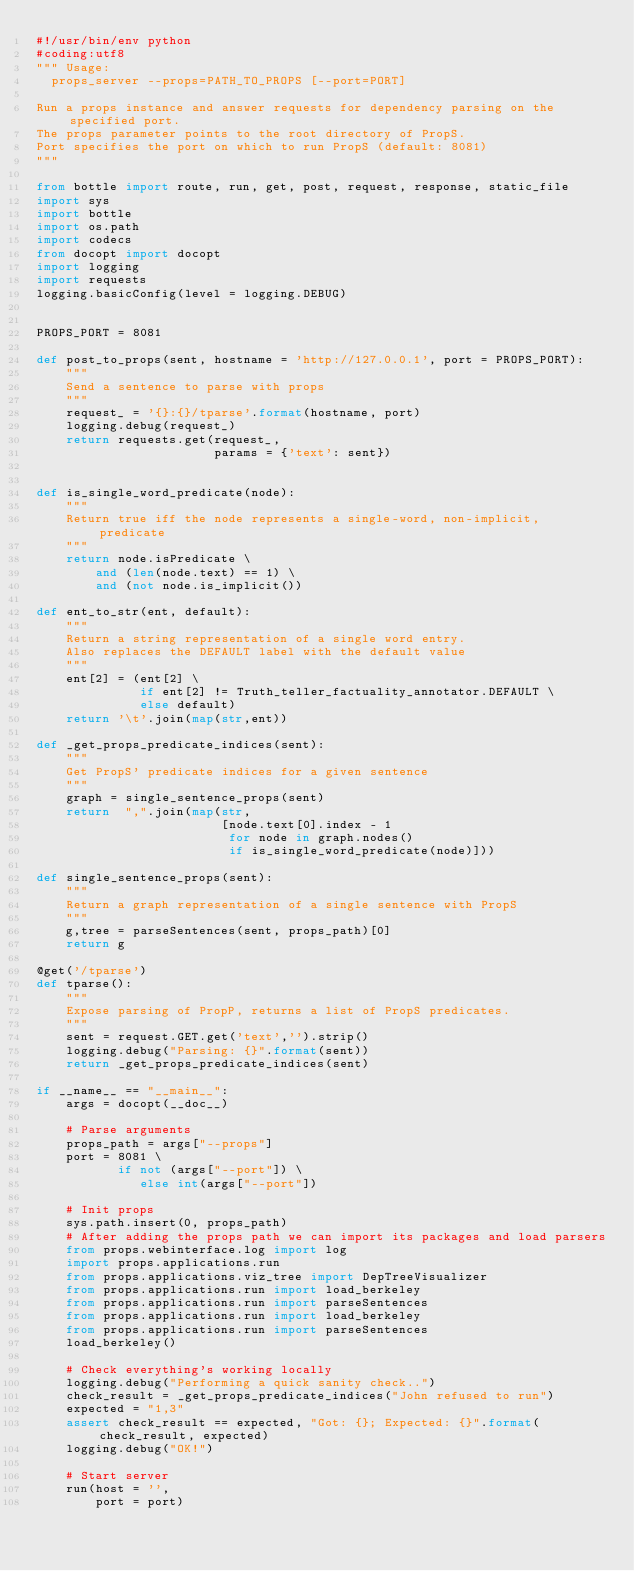Convert code to text. <code><loc_0><loc_0><loc_500><loc_500><_Python_>#!/usr/bin/env python
#coding:utf8
""" Usage:
  props_server --props=PATH_TO_PROPS [--port=PORT]

Run a props instance and answer requests for dependency parsing on the specified port.
The props parameter points to the root directory of PropS.
Port specifies the port on which to run PropS (default: 8081)
"""

from bottle import route, run, get, post, request, response, static_file
import sys
import bottle
import os.path
import codecs
from docopt import docopt
import logging
import requests
logging.basicConfig(level = logging.DEBUG)


PROPS_PORT = 8081

def post_to_props(sent, hostname = 'http://127.0.0.1', port = PROPS_PORT):
    """
    Send a sentence to parse with props
    """
    request_ = '{}:{}/tparse'.format(hostname, port)
    logging.debug(request_)
    return requests.get(request_,
                        params = {'text': sent})


def is_single_word_predicate(node):
    """
    Return true iff the node represents a single-word, non-implicit, predicate
    """
    return node.isPredicate \
        and (len(node.text) == 1) \
        and (not node.is_implicit())

def ent_to_str(ent, default):
    """
    Return a string representation of a single word entry.
    Also replaces the DEFAULT label with the default value
    """
    ent[2] = (ent[2] \
              if ent[2] != Truth_teller_factuality_annotator.DEFAULT \
              else default)
    return '\t'.join(map(str,ent))

def _get_props_predicate_indices(sent):
    """
    Get PropS' predicate indices for a given sentence
    """
    graph = single_sentence_props(sent)
    return  ",".join(map(str,
                         [node.text[0].index - 1
                          for node in graph.nodes()
                          if is_single_word_predicate(node)]))

def single_sentence_props(sent):
    """
    Return a graph representation of a single sentence with PropS
    """
    g,tree = parseSentences(sent, props_path)[0]
    return g

@get('/tparse')
def tparse():
    """
    Expose parsing of PropP, returns a list of PropS predicates.
    """
    sent = request.GET.get('text','').strip()
    logging.debug("Parsing: {}".format(sent))
    return _get_props_predicate_indices(sent)

if __name__ == "__main__":
    args = docopt(__doc__)

    # Parse arguments
    props_path = args["--props"]
    port = 8081 \
           if not (args["--port"]) \
              else int(args["--port"])

    # Init props
    sys.path.insert(0, props_path)
    # After adding the props path we can import its packages and load parsers
    from props.webinterface.log import log
    import props.applications.run
    from props.applications.viz_tree import DepTreeVisualizer
    from props.applications.run import load_berkeley
    from props.applications.run import parseSentences
    from props.applications.run import load_berkeley
    from props.applications.run import parseSentences
    load_berkeley()

    # Check everything's working locally
    logging.debug("Performing a quick sanity check..")
    check_result = _get_props_predicate_indices("John refused to run")
    expected = "1,3"
    assert check_result == expected, "Got: {}; Expected: {}".format(check_result, expected)
    logging.debug("OK!")

    # Start server
    run(host = '',
        port = port)
</code> 